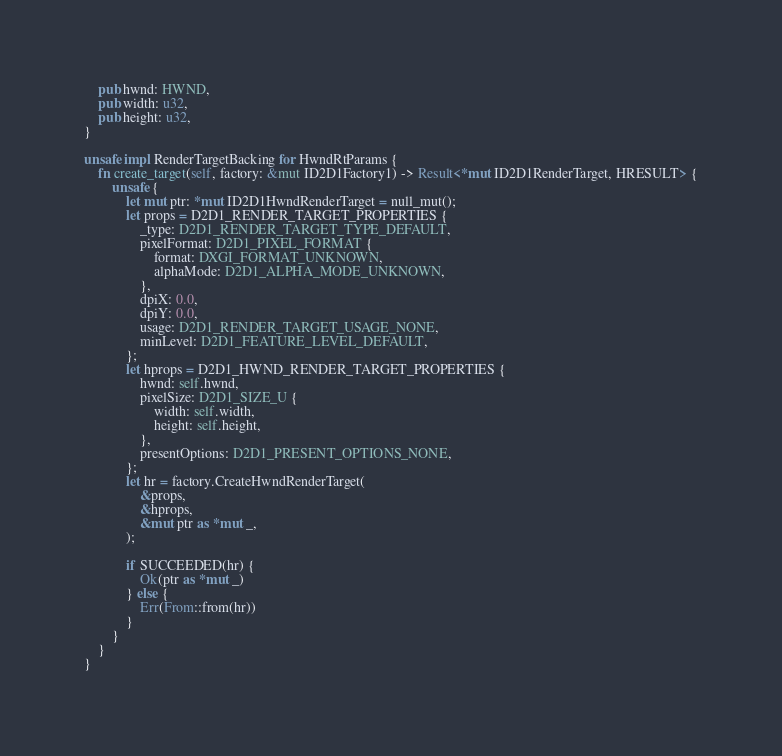<code> <loc_0><loc_0><loc_500><loc_500><_Rust_>    pub hwnd: HWND,
    pub width: u32,
    pub height: u32,
}

unsafe impl RenderTargetBacking for HwndRtParams {
    fn create_target(self, factory: &mut ID2D1Factory1) -> Result<*mut ID2D1RenderTarget, HRESULT> {
        unsafe {
            let mut ptr: *mut ID2D1HwndRenderTarget = null_mut();
            let props = D2D1_RENDER_TARGET_PROPERTIES {
                _type: D2D1_RENDER_TARGET_TYPE_DEFAULT,
                pixelFormat: D2D1_PIXEL_FORMAT {
                    format: DXGI_FORMAT_UNKNOWN,
                    alphaMode: D2D1_ALPHA_MODE_UNKNOWN,
                },
                dpiX: 0.0,
                dpiY: 0.0,
                usage: D2D1_RENDER_TARGET_USAGE_NONE,
                minLevel: D2D1_FEATURE_LEVEL_DEFAULT,
            };
            let hprops = D2D1_HWND_RENDER_TARGET_PROPERTIES {
                hwnd: self.hwnd,
                pixelSize: D2D1_SIZE_U {
                    width: self.width,
                    height: self.height,
                },
                presentOptions: D2D1_PRESENT_OPTIONS_NONE,
            };
            let hr = factory.CreateHwndRenderTarget(
                &props,
                &hprops,
                &mut ptr as *mut _,
            );

            if SUCCEEDED(hr) {
                Ok(ptr as *mut _)
            } else {
                Err(From::from(hr))
            }
        }
    }
}
</code> 